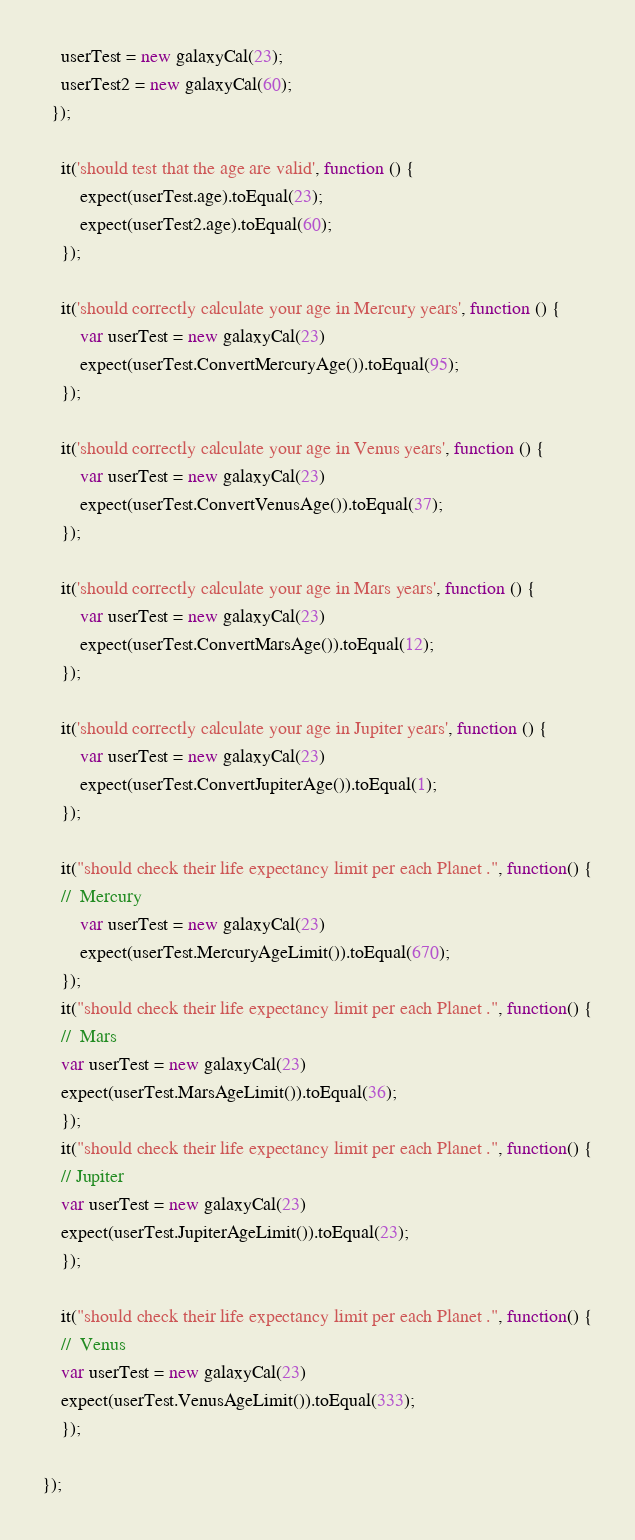Convert code to text. <code><loc_0><loc_0><loc_500><loc_500><_JavaScript_>    userTest = new galaxyCal(23);
    userTest2 = new galaxyCal(60);
  });

    it('should test that the age are valid', function () {
        expect(userTest.age).toEqual(23);
        expect(userTest2.age).toEqual(60);
    });

    it('should correctly calculate your age in Mercury years', function () {
        var userTest = new galaxyCal(23)
        expect(userTest.ConvertMercuryAge()).toEqual(95);     
    });

    it('should correctly calculate your age in Venus years', function () {
        var userTest = new galaxyCal(23)
        expect(userTest.ConvertVenusAge()).toEqual(37);
    });

    it('should correctly calculate your age in Mars years', function () {
        var userTest = new galaxyCal(23)
        expect(userTest.ConvertMarsAge()).toEqual(12);
    });

    it('should correctly calculate your age in Jupiter years', function () {
        var userTest = new galaxyCal(23)
        expect(userTest.ConvertJupiterAge()).toEqual(1);
    });

    it("should check their life expectancy limit per each Planet .", function() {
    //  Mercury
        var userTest = new galaxyCal(23)
        expect(userTest.MercuryAgeLimit()).toEqual(670);
    });
    it("should check their life expectancy limit per each Planet .", function() {
    //  Mars
    var userTest = new galaxyCal(23)
    expect(userTest.MarsAgeLimit()).toEqual(36);
    });
    it("should check their life expectancy limit per each Planet .", function() {
    // Jupiter
    var userTest = new galaxyCal(23)
    expect(userTest.JupiterAgeLimit()).toEqual(23);
    });

    it("should check their life expectancy limit per each Planet .", function() {
    //  Venus
    var userTest = new galaxyCal(23)
    expect(userTest.VenusAgeLimit()).toEqual(333);
    });

});
</code> 